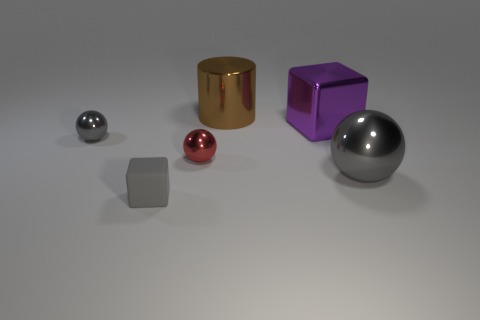Is there any object that stands out due to its unique surface finish? Indeed, the golden cylinder has a distinct surface that is highly reflective, suggesting a smooth and possibly polished finish, setting it apart from the other objects with various levels of matte and metallic appearance. 